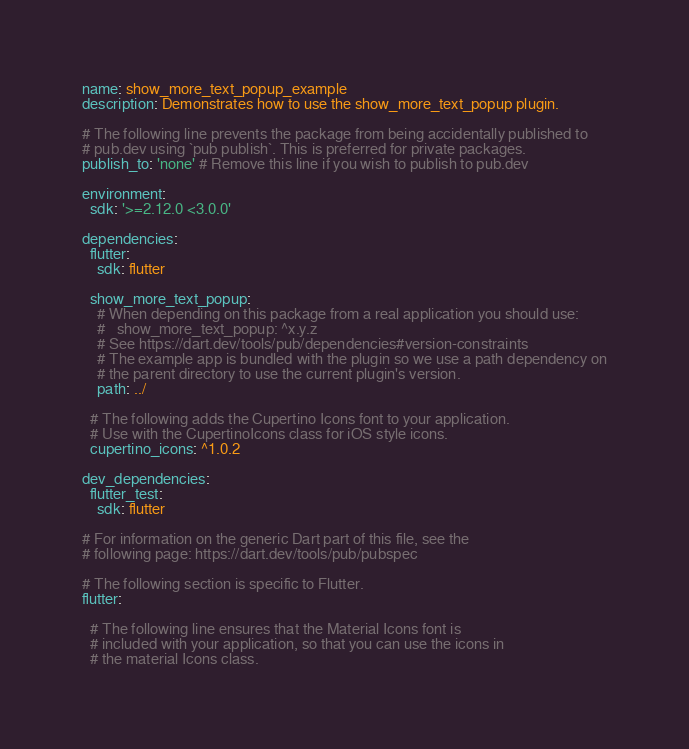Convert code to text. <code><loc_0><loc_0><loc_500><loc_500><_YAML_>name: show_more_text_popup_example
description: Demonstrates how to use the show_more_text_popup plugin.

# The following line prevents the package from being accidentally published to
# pub.dev using `pub publish`. This is preferred for private packages.
publish_to: 'none' # Remove this line if you wish to publish to pub.dev

environment:
  sdk: '>=2.12.0 <3.0.0'

dependencies:
  flutter:
    sdk: flutter

  show_more_text_popup:
    # When depending on this package from a real application you should use:
    #   show_more_text_popup: ^x.y.z
    # See https://dart.dev/tools/pub/dependencies#version-constraints
    # The example app is bundled with the plugin so we use a path dependency on
    # the parent directory to use the current plugin's version. 
    path: ../

  # The following adds the Cupertino Icons font to your application.
  # Use with the CupertinoIcons class for iOS style icons.
  cupertino_icons: ^1.0.2

dev_dependencies:
  flutter_test:
    sdk: flutter

# For information on the generic Dart part of this file, see the
# following page: https://dart.dev/tools/pub/pubspec

# The following section is specific to Flutter.
flutter:

  # The following line ensures that the Material Icons font is
  # included with your application, so that you can use the icons in
  # the material Icons class.</code> 